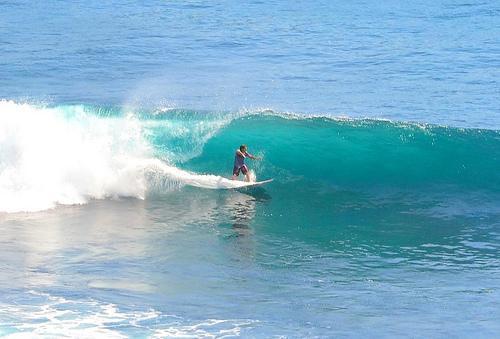How many people are in the photo?
Give a very brief answer. 1. 